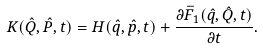<formula> <loc_0><loc_0><loc_500><loc_500>K ( \hat { Q } , \hat { P } , t ) = H ( \hat { q } , \hat { p } , t ) + \frac { \partial \bar { F } _ { 1 } ( \hat { q } , \hat { Q } , t ) } { \partial t } .</formula> 